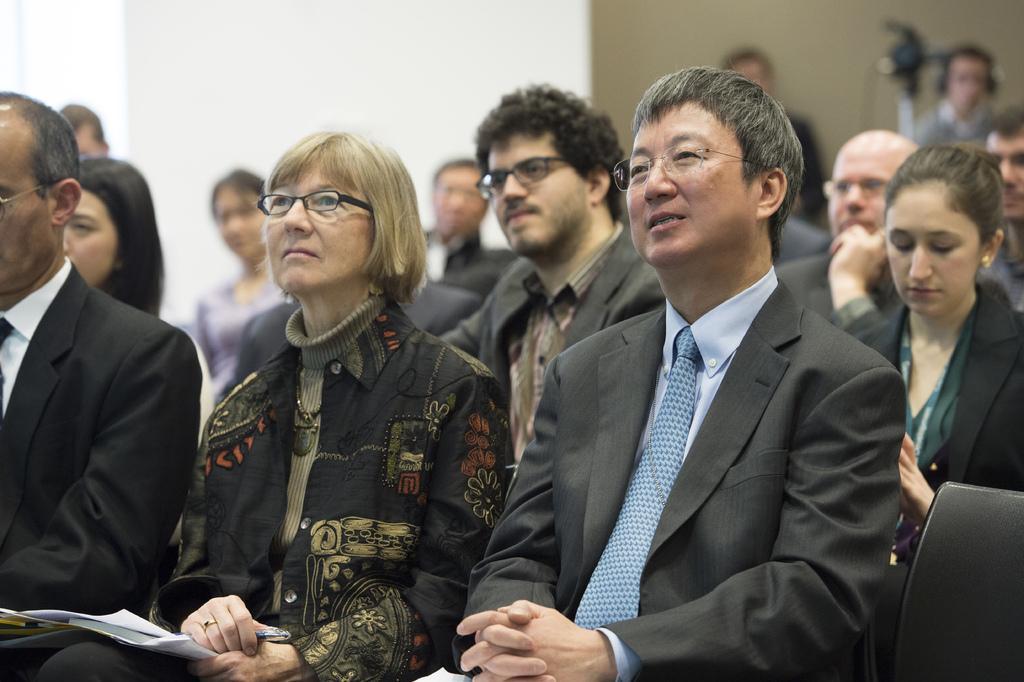How would you summarize this image in a sentence or two? In this picture we can see a group of people are sitting on chairs, papers, pen and some people wore spectacles. In the background we can see the wall, camera, two people and it is blurry. 